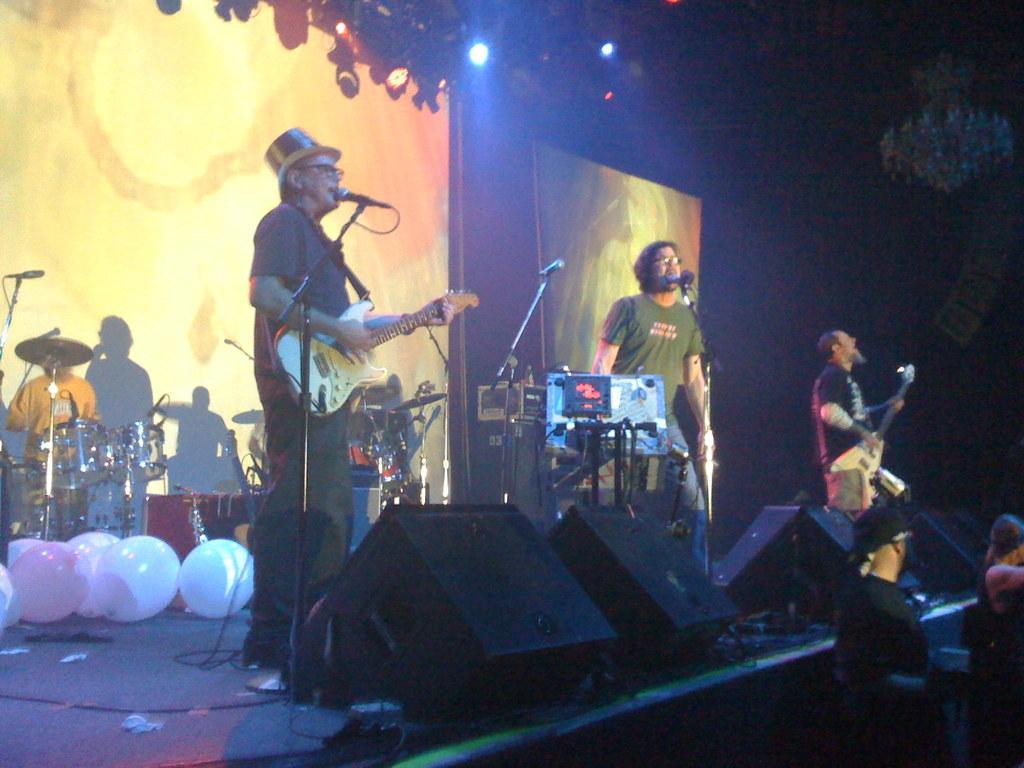Describe this image in one or two sentences. In this image I can see few people standing on the stage. Among them two people are playing the musical instruments. On the stage there are balloons and the musical instruments. In front of these people there are two people standing. In the background there is a banner. 